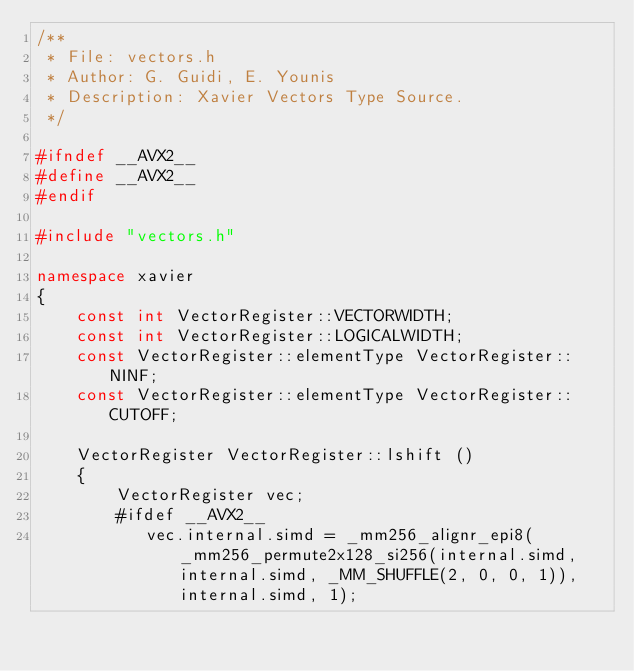<code> <loc_0><loc_0><loc_500><loc_500><_C++_>/**
 * File: vectors.h
 * Author: G. Guidi, E. Younis
 * Description: Xavier Vectors Type Source.
 */

#ifndef __AVX2__
#define __AVX2__
#endif

#include "vectors.h"

namespace xavier
{
	const int VectorRegister::VECTORWIDTH;
	const int VectorRegister::LOGICALWIDTH;
	const VectorRegister::elementType VectorRegister::NINF;
	const VectorRegister::elementType VectorRegister::CUTOFF;

    VectorRegister VectorRegister::lshift ()
    {
    	VectorRegister vec;
        #ifdef __AVX2__
     	   vec.internal.simd = _mm256_alignr_epi8(_mm256_permute2x128_si256(internal.simd, internal.simd, _MM_SHUFFLE(2, 0, 0, 1)), internal.simd, 1);</code> 